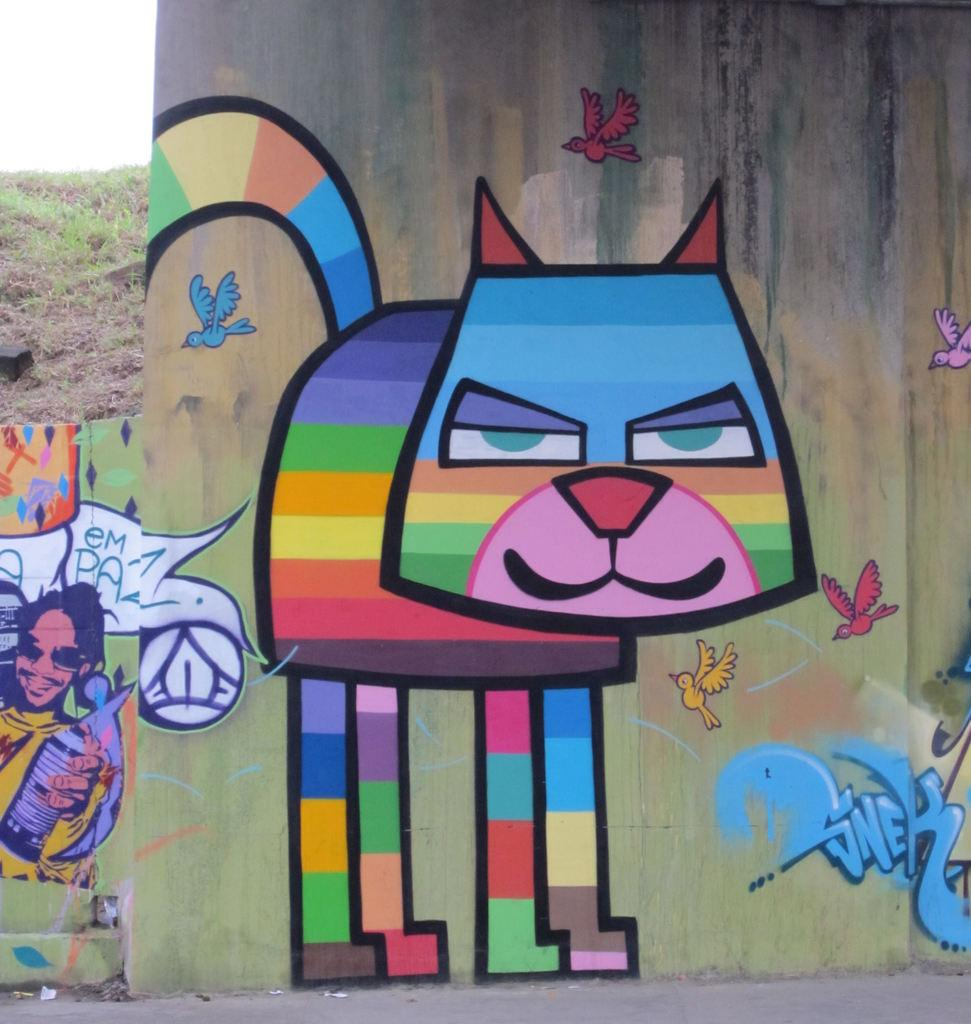What is on the wall in the image? There is a painting on the wall in the image. What subjects are depicted in the painting? The painting depicts a person, a cat, and birds. Are there any other elements in the painting? Yes, there are other things depicted in the painting. What can be seen in the background of the image? There is grass visible in the background of the image. Can you tell me how many vans are parked in the grass in the image? There are no vans present in the image; it only features a painting on a wall with various subjects. What type of pump is being used by the person in the painting? There is no pump depicted in the painting; the person is not using any such object. 